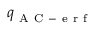<formula> <loc_0><loc_0><loc_500><loc_500>q _ { A C - e r f }</formula> 